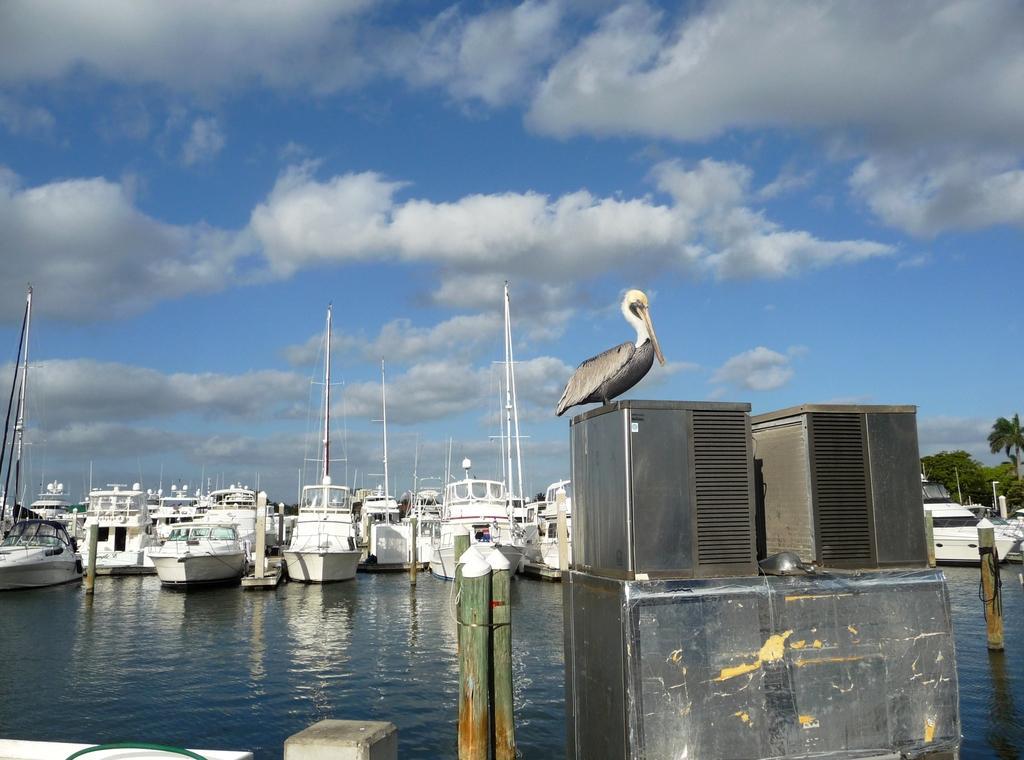Can you describe this image briefly? In this image I can see a bird is sitting on a metal rod, fence and fleets of boats in the water. At the top I can see the sky. This image is taken may be near the ocean. 